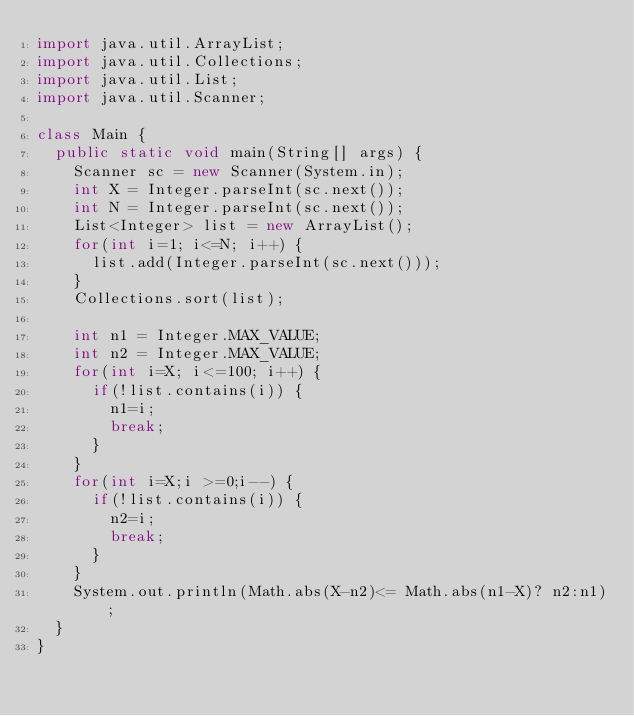<code> <loc_0><loc_0><loc_500><loc_500><_Java_>import java.util.ArrayList;
import java.util.Collections;
import java.util.List;
import java.util.Scanner;

class Main {
	public static void main(String[] args) {
		Scanner sc = new Scanner(System.in);
		int X = Integer.parseInt(sc.next());
		int N = Integer.parseInt(sc.next());
		List<Integer> list = new ArrayList();
		for(int i=1; i<=N; i++) {
			list.add(Integer.parseInt(sc.next()));
		}
		Collections.sort(list);

		int n1 = Integer.MAX_VALUE;
		int n2 = Integer.MAX_VALUE;
		for(int i=X; i<=100; i++) {
			if(!list.contains(i)) {
				n1=i;
				break;
			}
		}
		for(int i=X;i >=0;i--) {
			if(!list.contains(i)) {
				n2=i;
				break;
			}
		}
		System.out.println(Math.abs(X-n2)<= Math.abs(n1-X)? n2:n1);
	}
}
</code> 